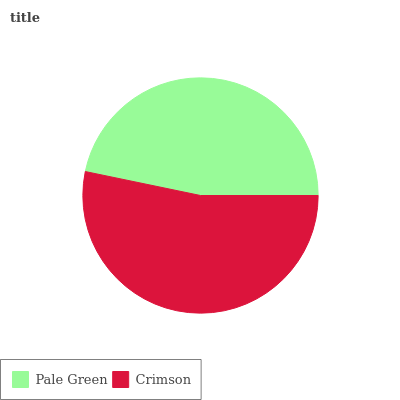Is Pale Green the minimum?
Answer yes or no. Yes. Is Crimson the maximum?
Answer yes or no. Yes. Is Crimson the minimum?
Answer yes or no. No. Is Crimson greater than Pale Green?
Answer yes or no. Yes. Is Pale Green less than Crimson?
Answer yes or no. Yes. Is Pale Green greater than Crimson?
Answer yes or no. No. Is Crimson less than Pale Green?
Answer yes or no. No. Is Crimson the high median?
Answer yes or no. Yes. Is Pale Green the low median?
Answer yes or no. Yes. Is Pale Green the high median?
Answer yes or no. No. Is Crimson the low median?
Answer yes or no. No. 